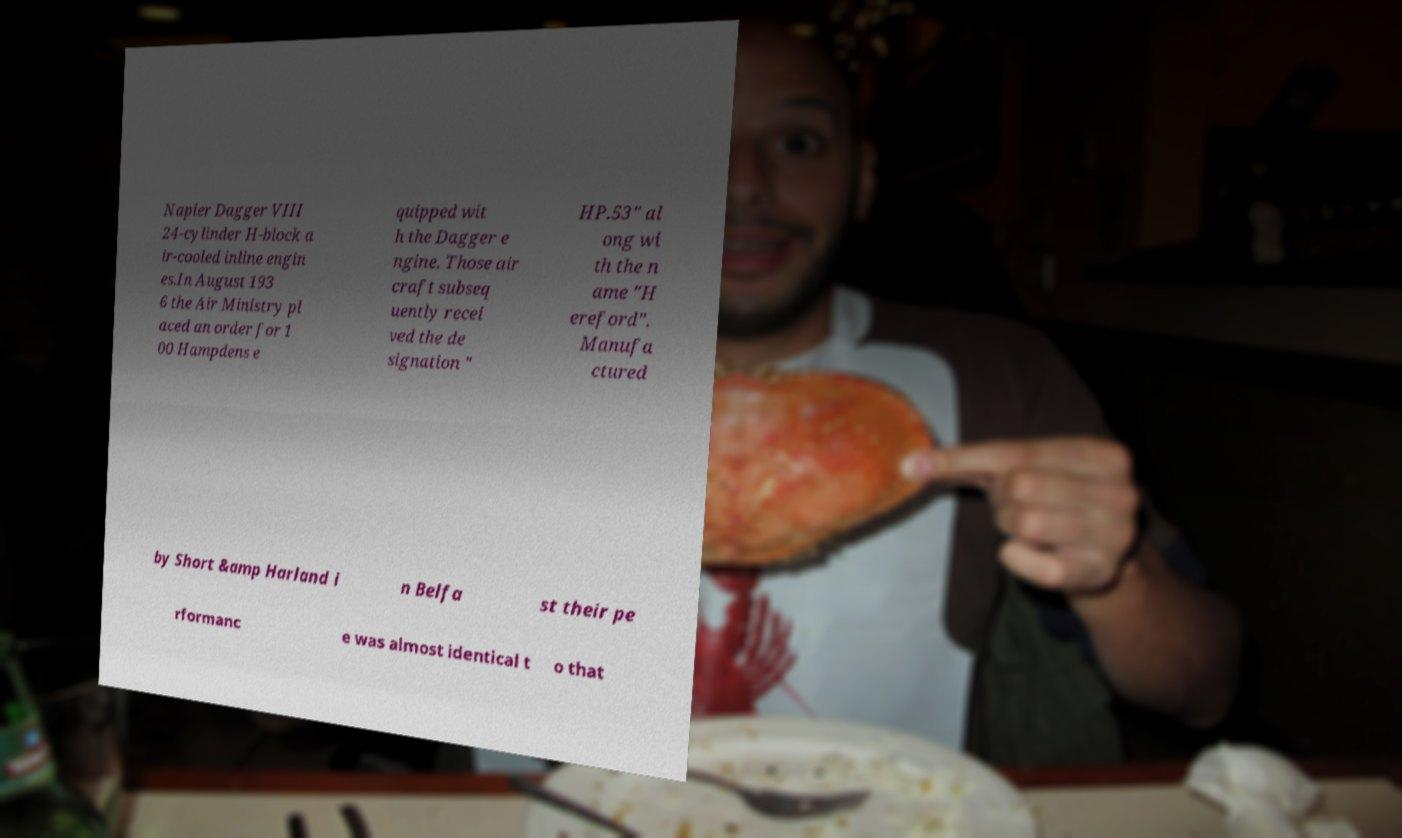Could you assist in decoding the text presented in this image and type it out clearly? Napier Dagger VIII 24-cylinder H-block a ir-cooled inline engin es.In August 193 6 the Air Ministry pl aced an order for 1 00 Hampdens e quipped wit h the Dagger e ngine. Those air craft subseq uently recei ved the de signation " HP.53" al ong wi th the n ame "H ereford". Manufa ctured by Short &amp Harland i n Belfa st their pe rformanc e was almost identical t o that 